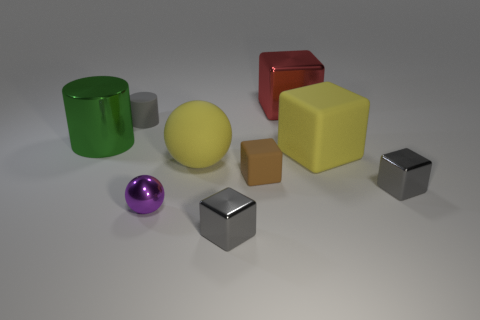What color is the other big thing that is the same material as the large green object?
Your response must be concise. Red. There is a tiny cube in front of the gray metallic block to the right of the yellow rubber object behind the large yellow sphere; what is its color?
Your response must be concise. Gray. What number of cylinders are tiny things or small gray shiny things?
Your answer should be very brief. 1. What material is the large thing that is the same color as the rubber ball?
Your response must be concise. Rubber. There is a matte sphere; is its color the same as the tiny rubber thing that is right of the big yellow ball?
Your response must be concise. No. The rubber cylinder is what color?
Your answer should be very brief. Gray. How many things are brown metallic things or gray objects?
Provide a succinct answer. 3. There is a brown block that is the same size as the matte cylinder; what is its material?
Keep it short and to the point. Rubber. There is a ball that is to the right of the small purple thing; what is its size?
Give a very brief answer. Large. What material is the big yellow cube?
Offer a very short reply. Rubber. 